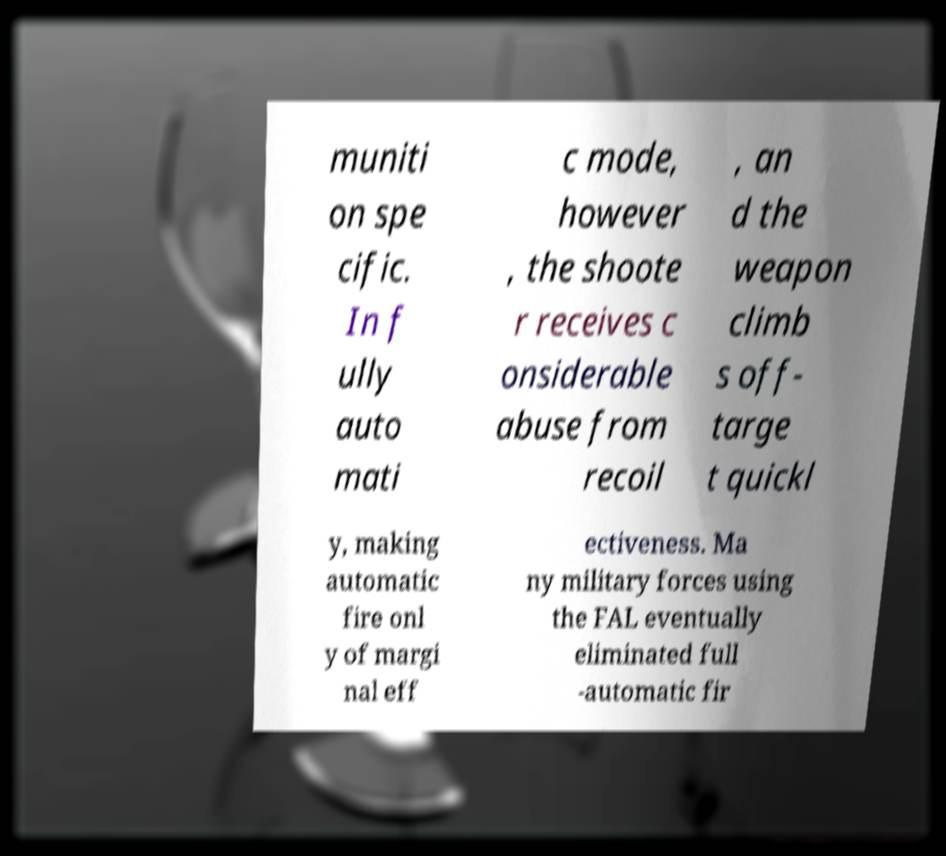Could you extract and type out the text from this image? muniti on spe cific. In f ully auto mati c mode, however , the shoote r receives c onsiderable abuse from recoil , an d the weapon climb s off- targe t quickl y, making automatic fire onl y of margi nal eff ectiveness. Ma ny military forces using the FAL eventually eliminated full -automatic fir 